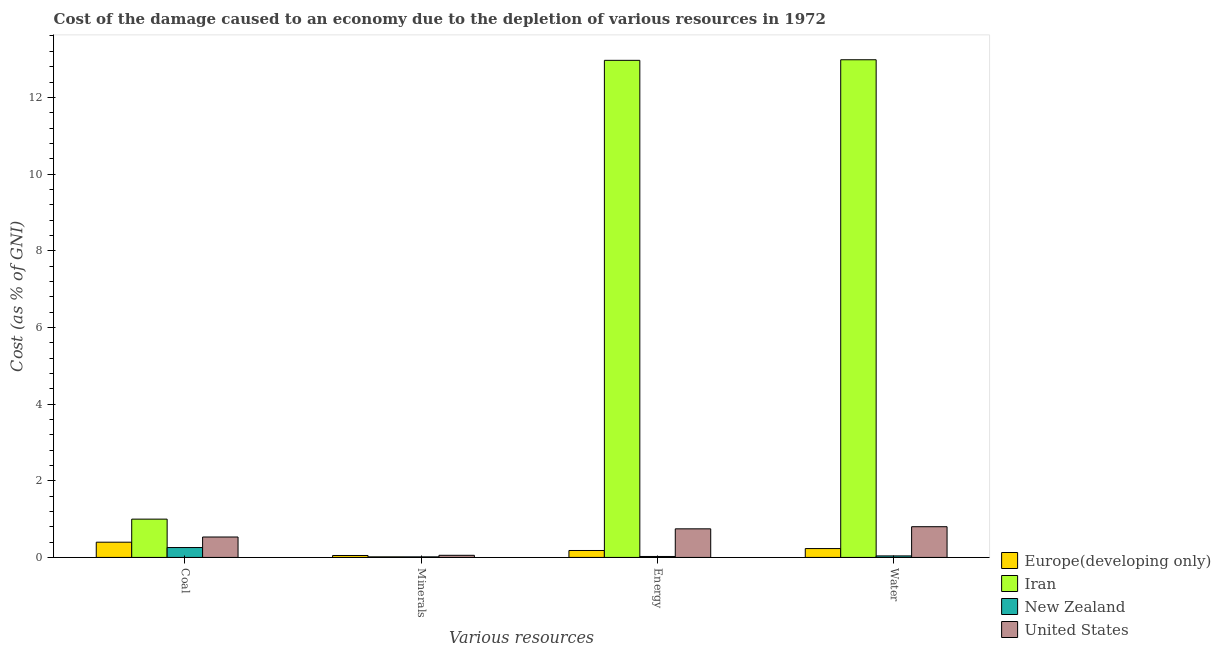How many different coloured bars are there?
Provide a short and direct response. 4. Are the number of bars per tick equal to the number of legend labels?
Offer a very short reply. Yes. Are the number of bars on each tick of the X-axis equal?
Offer a very short reply. Yes. What is the label of the 3rd group of bars from the left?
Give a very brief answer. Energy. What is the cost of damage due to depletion of energy in Europe(developing only)?
Provide a succinct answer. 0.18. Across all countries, what is the maximum cost of damage due to depletion of energy?
Your answer should be very brief. 12.97. Across all countries, what is the minimum cost of damage due to depletion of coal?
Your response must be concise. 0.26. In which country was the cost of damage due to depletion of energy maximum?
Provide a short and direct response. Iran. In which country was the cost of damage due to depletion of coal minimum?
Your answer should be very brief. New Zealand. What is the total cost of damage due to depletion of energy in the graph?
Ensure brevity in your answer.  13.92. What is the difference between the cost of damage due to depletion of energy in Iran and that in United States?
Ensure brevity in your answer.  12.22. What is the difference between the cost of damage due to depletion of energy in Iran and the cost of damage due to depletion of minerals in United States?
Ensure brevity in your answer.  12.91. What is the average cost of damage due to depletion of energy per country?
Your answer should be compact. 3.48. What is the difference between the cost of damage due to depletion of coal and cost of damage due to depletion of water in Europe(developing only)?
Provide a short and direct response. 0.17. What is the ratio of the cost of damage due to depletion of water in Europe(developing only) to that in Iran?
Ensure brevity in your answer.  0.02. Is the difference between the cost of damage due to depletion of minerals in United States and Europe(developing only) greater than the difference between the cost of damage due to depletion of water in United States and Europe(developing only)?
Provide a succinct answer. No. What is the difference between the highest and the second highest cost of damage due to depletion of minerals?
Offer a very short reply. 0. What is the difference between the highest and the lowest cost of damage due to depletion of coal?
Offer a terse response. 0.74. Is the sum of the cost of damage due to depletion of minerals in New Zealand and United States greater than the maximum cost of damage due to depletion of water across all countries?
Offer a very short reply. No. Is it the case that in every country, the sum of the cost of damage due to depletion of energy and cost of damage due to depletion of coal is greater than the sum of cost of damage due to depletion of minerals and cost of damage due to depletion of water?
Give a very brief answer. No. What does the 1st bar from the left in Coal represents?
Provide a short and direct response. Europe(developing only). What does the 3rd bar from the right in Water represents?
Provide a succinct answer. Iran. How many bars are there?
Your answer should be compact. 16. Are all the bars in the graph horizontal?
Your answer should be very brief. No. How many countries are there in the graph?
Your answer should be very brief. 4. Are the values on the major ticks of Y-axis written in scientific E-notation?
Keep it short and to the point. No. Where does the legend appear in the graph?
Your answer should be very brief. Bottom right. How many legend labels are there?
Your answer should be compact. 4. What is the title of the graph?
Offer a terse response. Cost of the damage caused to an economy due to the depletion of various resources in 1972 . Does "New Caledonia" appear as one of the legend labels in the graph?
Your response must be concise. No. What is the label or title of the X-axis?
Offer a terse response. Various resources. What is the label or title of the Y-axis?
Offer a very short reply. Cost (as % of GNI). What is the Cost (as % of GNI) of Europe(developing only) in Coal?
Keep it short and to the point. 0.4. What is the Cost (as % of GNI) of Iran in Coal?
Your response must be concise. 1. What is the Cost (as % of GNI) of New Zealand in Coal?
Your response must be concise. 0.26. What is the Cost (as % of GNI) of United States in Coal?
Your response must be concise. 0.53. What is the Cost (as % of GNI) of Europe(developing only) in Minerals?
Your response must be concise. 0.05. What is the Cost (as % of GNI) in Iran in Minerals?
Offer a very short reply. 0.02. What is the Cost (as % of GNI) in New Zealand in Minerals?
Offer a terse response. 0.01. What is the Cost (as % of GNI) of United States in Minerals?
Your answer should be very brief. 0.06. What is the Cost (as % of GNI) in Europe(developing only) in Energy?
Give a very brief answer. 0.18. What is the Cost (as % of GNI) in Iran in Energy?
Offer a very short reply. 12.97. What is the Cost (as % of GNI) in New Zealand in Energy?
Keep it short and to the point. 0.02. What is the Cost (as % of GNI) in United States in Energy?
Provide a short and direct response. 0.75. What is the Cost (as % of GNI) in Europe(developing only) in Water?
Give a very brief answer. 0.23. What is the Cost (as % of GNI) in Iran in Water?
Your answer should be very brief. 12.98. What is the Cost (as % of GNI) in New Zealand in Water?
Ensure brevity in your answer.  0.04. What is the Cost (as % of GNI) of United States in Water?
Your response must be concise. 0.8. Across all Various resources, what is the maximum Cost (as % of GNI) in Europe(developing only)?
Your answer should be compact. 0.4. Across all Various resources, what is the maximum Cost (as % of GNI) in Iran?
Offer a terse response. 12.98. Across all Various resources, what is the maximum Cost (as % of GNI) in New Zealand?
Provide a succinct answer. 0.26. Across all Various resources, what is the maximum Cost (as % of GNI) in United States?
Give a very brief answer. 0.8. Across all Various resources, what is the minimum Cost (as % of GNI) of Europe(developing only)?
Keep it short and to the point. 0.05. Across all Various resources, what is the minimum Cost (as % of GNI) of Iran?
Your answer should be compact. 0.02. Across all Various resources, what is the minimum Cost (as % of GNI) in New Zealand?
Your response must be concise. 0.01. Across all Various resources, what is the minimum Cost (as % of GNI) in United States?
Your response must be concise. 0.06. What is the total Cost (as % of GNI) in Europe(developing only) in the graph?
Your answer should be very brief. 0.86. What is the total Cost (as % of GNI) in Iran in the graph?
Your answer should be very brief. 26.96. What is the total Cost (as % of GNI) in New Zealand in the graph?
Keep it short and to the point. 0.34. What is the total Cost (as % of GNI) of United States in the graph?
Give a very brief answer. 2.13. What is the difference between the Cost (as % of GNI) in Europe(developing only) in Coal and that in Minerals?
Your answer should be very brief. 0.35. What is the difference between the Cost (as % of GNI) in Iran in Coal and that in Minerals?
Give a very brief answer. 0.98. What is the difference between the Cost (as % of GNI) of New Zealand in Coal and that in Minerals?
Your response must be concise. 0.24. What is the difference between the Cost (as % of GNI) in United States in Coal and that in Minerals?
Your answer should be very brief. 0.48. What is the difference between the Cost (as % of GNI) of Europe(developing only) in Coal and that in Energy?
Provide a short and direct response. 0.22. What is the difference between the Cost (as % of GNI) of Iran in Coal and that in Energy?
Offer a very short reply. -11.97. What is the difference between the Cost (as % of GNI) of New Zealand in Coal and that in Energy?
Your response must be concise. 0.23. What is the difference between the Cost (as % of GNI) in United States in Coal and that in Energy?
Keep it short and to the point. -0.21. What is the difference between the Cost (as % of GNI) in Europe(developing only) in Coal and that in Water?
Offer a terse response. 0.17. What is the difference between the Cost (as % of GNI) of Iran in Coal and that in Water?
Keep it short and to the point. -11.98. What is the difference between the Cost (as % of GNI) in New Zealand in Coal and that in Water?
Give a very brief answer. 0.22. What is the difference between the Cost (as % of GNI) in United States in Coal and that in Water?
Offer a terse response. -0.27. What is the difference between the Cost (as % of GNI) in Europe(developing only) in Minerals and that in Energy?
Give a very brief answer. -0.13. What is the difference between the Cost (as % of GNI) in Iran in Minerals and that in Energy?
Provide a succinct answer. -12.95. What is the difference between the Cost (as % of GNI) of New Zealand in Minerals and that in Energy?
Give a very brief answer. -0.01. What is the difference between the Cost (as % of GNI) of United States in Minerals and that in Energy?
Give a very brief answer. -0.69. What is the difference between the Cost (as % of GNI) in Europe(developing only) in Minerals and that in Water?
Provide a short and direct response. -0.18. What is the difference between the Cost (as % of GNI) of Iran in Minerals and that in Water?
Your answer should be compact. -12.97. What is the difference between the Cost (as % of GNI) of New Zealand in Minerals and that in Water?
Offer a very short reply. -0.02. What is the difference between the Cost (as % of GNI) in United States in Minerals and that in Water?
Offer a very short reply. -0.75. What is the difference between the Cost (as % of GNI) in Europe(developing only) in Energy and that in Water?
Your answer should be compact. -0.05. What is the difference between the Cost (as % of GNI) in Iran in Energy and that in Water?
Your answer should be very brief. -0.01. What is the difference between the Cost (as % of GNI) of New Zealand in Energy and that in Water?
Provide a succinct answer. -0.01. What is the difference between the Cost (as % of GNI) of United States in Energy and that in Water?
Your answer should be compact. -0.06. What is the difference between the Cost (as % of GNI) in Europe(developing only) in Coal and the Cost (as % of GNI) in Iran in Minerals?
Your answer should be compact. 0.38. What is the difference between the Cost (as % of GNI) in Europe(developing only) in Coal and the Cost (as % of GNI) in New Zealand in Minerals?
Provide a short and direct response. 0.38. What is the difference between the Cost (as % of GNI) of Europe(developing only) in Coal and the Cost (as % of GNI) of United States in Minerals?
Ensure brevity in your answer.  0.34. What is the difference between the Cost (as % of GNI) in Iran in Coal and the Cost (as % of GNI) in New Zealand in Minerals?
Offer a terse response. 0.98. What is the difference between the Cost (as % of GNI) of Iran in Coal and the Cost (as % of GNI) of United States in Minerals?
Offer a terse response. 0.94. What is the difference between the Cost (as % of GNI) in New Zealand in Coal and the Cost (as % of GNI) in United States in Minerals?
Give a very brief answer. 0.2. What is the difference between the Cost (as % of GNI) of Europe(developing only) in Coal and the Cost (as % of GNI) of Iran in Energy?
Give a very brief answer. -12.57. What is the difference between the Cost (as % of GNI) in Europe(developing only) in Coal and the Cost (as % of GNI) in New Zealand in Energy?
Provide a short and direct response. 0.37. What is the difference between the Cost (as % of GNI) of Europe(developing only) in Coal and the Cost (as % of GNI) of United States in Energy?
Make the answer very short. -0.35. What is the difference between the Cost (as % of GNI) of Iran in Coal and the Cost (as % of GNI) of New Zealand in Energy?
Ensure brevity in your answer.  0.97. What is the difference between the Cost (as % of GNI) in Iran in Coal and the Cost (as % of GNI) in United States in Energy?
Keep it short and to the point. 0.25. What is the difference between the Cost (as % of GNI) in New Zealand in Coal and the Cost (as % of GNI) in United States in Energy?
Ensure brevity in your answer.  -0.49. What is the difference between the Cost (as % of GNI) of Europe(developing only) in Coal and the Cost (as % of GNI) of Iran in Water?
Your response must be concise. -12.58. What is the difference between the Cost (as % of GNI) in Europe(developing only) in Coal and the Cost (as % of GNI) in New Zealand in Water?
Make the answer very short. 0.36. What is the difference between the Cost (as % of GNI) of Europe(developing only) in Coal and the Cost (as % of GNI) of United States in Water?
Make the answer very short. -0.4. What is the difference between the Cost (as % of GNI) of Iran in Coal and the Cost (as % of GNI) of New Zealand in Water?
Provide a succinct answer. 0.96. What is the difference between the Cost (as % of GNI) of Iran in Coal and the Cost (as % of GNI) of United States in Water?
Provide a succinct answer. 0.2. What is the difference between the Cost (as % of GNI) of New Zealand in Coal and the Cost (as % of GNI) of United States in Water?
Your answer should be very brief. -0.54. What is the difference between the Cost (as % of GNI) of Europe(developing only) in Minerals and the Cost (as % of GNI) of Iran in Energy?
Offer a very short reply. -12.91. What is the difference between the Cost (as % of GNI) of Europe(developing only) in Minerals and the Cost (as % of GNI) of New Zealand in Energy?
Keep it short and to the point. 0.03. What is the difference between the Cost (as % of GNI) in Europe(developing only) in Minerals and the Cost (as % of GNI) in United States in Energy?
Provide a succinct answer. -0.7. What is the difference between the Cost (as % of GNI) in Iran in Minerals and the Cost (as % of GNI) in New Zealand in Energy?
Provide a short and direct response. -0.01. What is the difference between the Cost (as % of GNI) in Iran in Minerals and the Cost (as % of GNI) in United States in Energy?
Offer a very short reply. -0.73. What is the difference between the Cost (as % of GNI) in New Zealand in Minerals and the Cost (as % of GNI) in United States in Energy?
Your answer should be very brief. -0.73. What is the difference between the Cost (as % of GNI) of Europe(developing only) in Minerals and the Cost (as % of GNI) of Iran in Water?
Provide a short and direct response. -12.93. What is the difference between the Cost (as % of GNI) in Europe(developing only) in Minerals and the Cost (as % of GNI) in New Zealand in Water?
Provide a succinct answer. 0.01. What is the difference between the Cost (as % of GNI) of Europe(developing only) in Minerals and the Cost (as % of GNI) of United States in Water?
Offer a very short reply. -0.75. What is the difference between the Cost (as % of GNI) of Iran in Minerals and the Cost (as % of GNI) of New Zealand in Water?
Your answer should be very brief. -0.02. What is the difference between the Cost (as % of GNI) in Iran in Minerals and the Cost (as % of GNI) in United States in Water?
Offer a very short reply. -0.79. What is the difference between the Cost (as % of GNI) of New Zealand in Minerals and the Cost (as % of GNI) of United States in Water?
Make the answer very short. -0.79. What is the difference between the Cost (as % of GNI) in Europe(developing only) in Energy and the Cost (as % of GNI) in Iran in Water?
Give a very brief answer. -12.8. What is the difference between the Cost (as % of GNI) of Europe(developing only) in Energy and the Cost (as % of GNI) of New Zealand in Water?
Your response must be concise. 0.14. What is the difference between the Cost (as % of GNI) in Europe(developing only) in Energy and the Cost (as % of GNI) in United States in Water?
Your answer should be very brief. -0.62. What is the difference between the Cost (as % of GNI) of Iran in Energy and the Cost (as % of GNI) of New Zealand in Water?
Offer a very short reply. 12.93. What is the difference between the Cost (as % of GNI) in Iran in Energy and the Cost (as % of GNI) in United States in Water?
Your answer should be compact. 12.16. What is the difference between the Cost (as % of GNI) of New Zealand in Energy and the Cost (as % of GNI) of United States in Water?
Give a very brief answer. -0.78. What is the average Cost (as % of GNI) of Europe(developing only) per Various resources?
Provide a short and direct response. 0.21. What is the average Cost (as % of GNI) in Iran per Various resources?
Offer a very short reply. 6.74. What is the average Cost (as % of GNI) in New Zealand per Various resources?
Your answer should be compact. 0.08. What is the average Cost (as % of GNI) in United States per Various resources?
Offer a very short reply. 0.53. What is the difference between the Cost (as % of GNI) of Europe(developing only) and Cost (as % of GNI) of Iran in Coal?
Your answer should be compact. -0.6. What is the difference between the Cost (as % of GNI) of Europe(developing only) and Cost (as % of GNI) of New Zealand in Coal?
Your answer should be compact. 0.14. What is the difference between the Cost (as % of GNI) in Europe(developing only) and Cost (as % of GNI) in United States in Coal?
Ensure brevity in your answer.  -0.14. What is the difference between the Cost (as % of GNI) of Iran and Cost (as % of GNI) of New Zealand in Coal?
Your answer should be compact. 0.74. What is the difference between the Cost (as % of GNI) of Iran and Cost (as % of GNI) of United States in Coal?
Keep it short and to the point. 0.47. What is the difference between the Cost (as % of GNI) of New Zealand and Cost (as % of GNI) of United States in Coal?
Give a very brief answer. -0.27. What is the difference between the Cost (as % of GNI) of Europe(developing only) and Cost (as % of GNI) of Iran in Minerals?
Your response must be concise. 0.04. What is the difference between the Cost (as % of GNI) in Europe(developing only) and Cost (as % of GNI) in New Zealand in Minerals?
Make the answer very short. 0.04. What is the difference between the Cost (as % of GNI) in Europe(developing only) and Cost (as % of GNI) in United States in Minerals?
Give a very brief answer. -0.01. What is the difference between the Cost (as % of GNI) of Iran and Cost (as % of GNI) of New Zealand in Minerals?
Provide a short and direct response. 0. What is the difference between the Cost (as % of GNI) of Iran and Cost (as % of GNI) of United States in Minerals?
Provide a short and direct response. -0.04. What is the difference between the Cost (as % of GNI) of New Zealand and Cost (as % of GNI) of United States in Minerals?
Ensure brevity in your answer.  -0.04. What is the difference between the Cost (as % of GNI) in Europe(developing only) and Cost (as % of GNI) in Iran in Energy?
Provide a succinct answer. -12.78. What is the difference between the Cost (as % of GNI) of Europe(developing only) and Cost (as % of GNI) of New Zealand in Energy?
Offer a terse response. 0.16. What is the difference between the Cost (as % of GNI) in Europe(developing only) and Cost (as % of GNI) in United States in Energy?
Your response must be concise. -0.56. What is the difference between the Cost (as % of GNI) in Iran and Cost (as % of GNI) in New Zealand in Energy?
Your answer should be compact. 12.94. What is the difference between the Cost (as % of GNI) in Iran and Cost (as % of GNI) in United States in Energy?
Your answer should be very brief. 12.22. What is the difference between the Cost (as % of GNI) in New Zealand and Cost (as % of GNI) in United States in Energy?
Provide a short and direct response. -0.72. What is the difference between the Cost (as % of GNI) of Europe(developing only) and Cost (as % of GNI) of Iran in Water?
Offer a terse response. -12.75. What is the difference between the Cost (as % of GNI) in Europe(developing only) and Cost (as % of GNI) in New Zealand in Water?
Your answer should be compact. 0.19. What is the difference between the Cost (as % of GNI) in Europe(developing only) and Cost (as % of GNI) in United States in Water?
Offer a very short reply. -0.57. What is the difference between the Cost (as % of GNI) of Iran and Cost (as % of GNI) of New Zealand in Water?
Offer a very short reply. 12.94. What is the difference between the Cost (as % of GNI) of Iran and Cost (as % of GNI) of United States in Water?
Your answer should be compact. 12.18. What is the difference between the Cost (as % of GNI) of New Zealand and Cost (as % of GNI) of United States in Water?
Your answer should be compact. -0.76. What is the ratio of the Cost (as % of GNI) in Europe(developing only) in Coal to that in Minerals?
Provide a succinct answer. 7.88. What is the ratio of the Cost (as % of GNI) in Iran in Coal to that in Minerals?
Your response must be concise. 66.41. What is the ratio of the Cost (as % of GNI) of New Zealand in Coal to that in Minerals?
Provide a succinct answer. 17.72. What is the ratio of the Cost (as % of GNI) in United States in Coal to that in Minerals?
Your answer should be very brief. 9.62. What is the ratio of the Cost (as % of GNI) of Europe(developing only) in Coal to that in Energy?
Give a very brief answer. 2.2. What is the ratio of the Cost (as % of GNI) of Iran in Coal to that in Energy?
Offer a very short reply. 0.08. What is the ratio of the Cost (as % of GNI) in New Zealand in Coal to that in Energy?
Provide a short and direct response. 10.34. What is the ratio of the Cost (as % of GNI) of United States in Coal to that in Energy?
Keep it short and to the point. 0.71. What is the ratio of the Cost (as % of GNI) in Europe(developing only) in Coal to that in Water?
Offer a terse response. 1.72. What is the ratio of the Cost (as % of GNI) of Iran in Coal to that in Water?
Your response must be concise. 0.08. What is the ratio of the Cost (as % of GNI) of New Zealand in Coal to that in Water?
Your answer should be compact. 6.53. What is the ratio of the Cost (as % of GNI) in United States in Coal to that in Water?
Provide a short and direct response. 0.66. What is the ratio of the Cost (as % of GNI) of Europe(developing only) in Minerals to that in Energy?
Your answer should be very brief. 0.28. What is the ratio of the Cost (as % of GNI) of Iran in Minerals to that in Energy?
Provide a succinct answer. 0. What is the ratio of the Cost (as % of GNI) of New Zealand in Minerals to that in Energy?
Your response must be concise. 0.58. What is the ratio of the Cost (as % of GNI) in United States in Minerals to that in Energy?
Ensure brevity in your answer.  0.07. What is the ratio of the Cost (as % of GNI) in Europe(developing only) in Minerals to that in Water?
Keep it short and to the point. 0.22. What is the ratio of the Cost (as % of GNI) of Iran in Minerals to that in Water?
Your answer should be compact. 0. What is the ratio of the Cost (as % of GNI) of New Zealand in Minerals to that in Water?
Keep it short and to the point. 0.37. What is the ratio of the Cost (as % of GNI) in United States in Minerals to that in Water?
Offer a terse response. 0.07. What is the ratio of the Cost (as % of GNI) of Europe(developing only) in Energy to that in Water?
Your answer should be compact. 0.78. What is the ratio of the Cost (as % of GNI) of Iran in Energy to that in Water?
Offer a very short reply. 1. What is the ratio of the Cost (as % of GNI) of New Zealand in Energy to that in Water?
Your answer should be compact. 0.63. What is the ratio of the Cost (as % of GNI) in United States in Energy to that in Water?
Your answer should be very brief. 0.93. What is the difference between the highest and the second highest Cost (as % of GNI) of Europe(developing only)?
Ensure brevity in your answer.  0.17. What is the difference between the highest and the second highest Cost (as % of GNI) of Iran?
Provide a succinct answer. 0.01. What is the difference between the highest and the second highest Cost (as % of GNI) in New Zealand?
Your answer should be very brief. 0.22. What is the difference between the highest and the second highest Cost (as % of GNI) in United States?
Your answer should be compact. 0.06. What is the difference between the highest and the lowest Cost (as % of GNI) in Europe(developing only)?
Your answer should be very brief. 0.35. What is the difference between the highest and the lowest Cost (as % of GNI) in Iran?
Offer a terse response. 12.97. What is the difference between the highest and the lowest Cost (as % of GNI) in New Zealand?
Provide a short and direct response. 0.24. What is the difference between the highest and the lowest Cost (as % of GNI) in United States?
Ensure brevity in your answer.  0.75. 